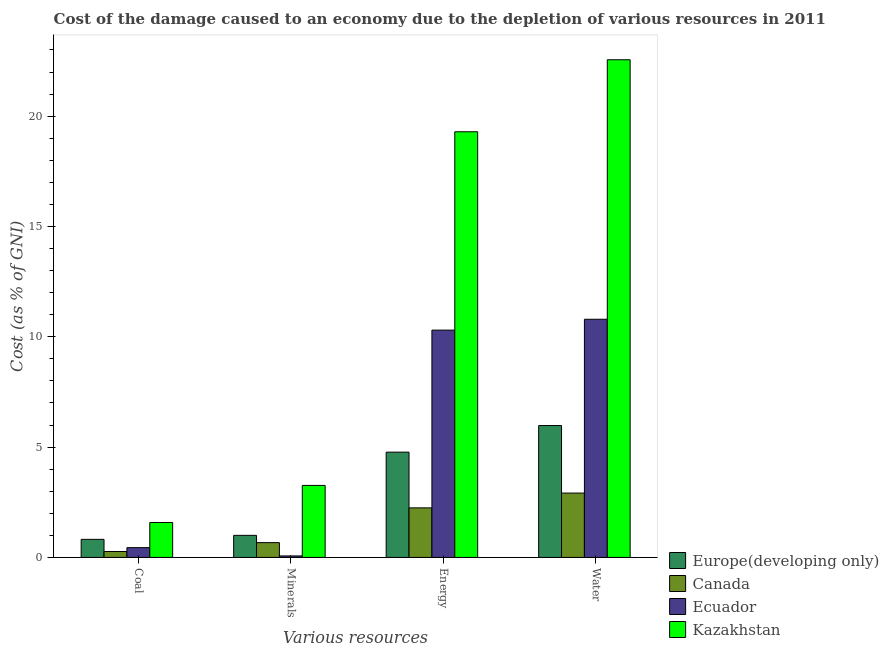How many different coloured bars are there?
Provide a succinct answer. 4. How many groups of bars are there?
Give a very brief answer. 4. What is the label of the 3rd group of bars from the left?
Your response must be concise. Energy. What is the cost of damage due to depletion of energy in Ecuador?
Offer a terse response. 10.3. Across all countries, what is the maximum cost of damage due to depletion of minerals?
Make the answer very short. 3.26. Across all countries, what is the minimum cost of damage due to depletion of water?
Give a very brief answer. 2.92. In which country was the cost of damage due to depletion of coal maximum?
Give a very brief answer. Kazakhstan. In which country was the cost of damage due to depletion of water minimum?
Your answer should be compact. Canada. What is the total cost of damage due to depletion of energy in the graph?
Your answer should be very brief. 36.61. What is the difference between the cost of damage due to depletion of coal in Ecuador and that in Canada?
Give a very brief answer. 0.18. What is the difference between the cost of damage due to depletion of minerals in Ecuador and the cost of damage due to depletion of energy in Canada?
Keep it short and to the point. -2.18. What is the average cost of damage due to depletion of coal per country?
Your answer should be very brief. 0.78. What is the difference between the cost of damage due to depletion of water and cost of damage due to depletion of coal in Canada?
Offer a very short reply. 2.65. What is the ratio of the cost of damage due to depletion of water in Ecuador to that in Europe(developing only)?
Provide a short and direct response. 1.81. Is the cost of damage due to depletion of coal in Ecuador less than that in Kazakhstan?
Keep it short and to the point. Yes. Is the difference between the cost of damage due to depletion of coal in Europe(developing only) and Canada greater than the difference between the cost of damage due to depletion of minerals in Europe(developing only) and Canada?
Your answer should be compact. Yes. What is the difference between the highest and the second highest cost of damage due to depletion of water?
Provide a short and direct response. 11.76. What is the difference between the highest and the lowest cost of damage due to depletion of water?
Your response must be concise. 19.64. Is the sum of the cost of damage due to depletion of water in Canada and Ecuador greater than the maximum cost of damage due to depletion of coal across all countries?
Give a very brief answer. Yes. Is it the case that in every country, the sum of the cost of damage due to depletion of coal and cost of damage due to depletion of minerals is greater than the sum of cost of damage due to depletion of energy and cost of damage due to depletion of water?
Your answer should be very brief. No. What does the 2nd bar from the left in Minerals represents?
Ensure brevity in your answer.  Canada. What does the 4th bar from the right in Minerals represents?
Make the answer very short. Europe(developing only). How many countries are there in the graph?
Your answer should be very brief. 4. What is the difference between two consecutive major ticks on the Y-axis?
Offer a terse response. 5. Does the graph contain grids?
Your answer should be compact. No. How many legend labels are there?
Your response must be concise. 4. How are the legend labels stacked?
Your answer should be compact. Vertical. What is the title of the graph?
Make the answer very short. Cost of the damage caused to an economy due to the depletion of various resources in 2011 . Does "Serbia" appear as one of the legend labels in the graph?
Your response must be concise. No. What is the label or title of the X-axis?
Ensure brevity in your answer.  Various resources. What is the label or title of the Y-axis?
Provide a short and direct response. Cost (as % of GNI). What is the Cost (as % of GNI) in Europe(developing only) in Coal?
Your response must be concise. 0.82. What is the Cost (as % of GNI) of Canada in Coal?
Your answer should be very brief. 0.27. What is the Cost (as % of GNI) in Ecuador in Coal?
Keep it short and to the point. 0.44. What is the Cost (as % of GNI) of Kazakhstan in Coal?
Your answer should be very brief. 1.58. What is the Cost (as % of GNI) of Europe(developing only) in Minerals?
Your answer should be very brief. 1. What is the Cost (as % of GNI) in Canada in Minerals?
Provide a short and direct response. 0.67. What is the Cost (as % of GNI) of Ecuador in Minerals?
Give a very brief answer. 0.07. What is the Cost (as % of GNI) in Kazakhstan in Minerals?
Make the answer very short. 3.26. What is the Cost (as % of GNI) in Europe(developing only) in Energy?
Ensure brevity in your answer.  4.77. What is the Cost (as % of GNI) in Canada in Energy?
Provide a short and direct response. 2.25. What is the Cost (as % of GNI) of Ecuador in Energy?
Keep it short and to the point. 10.3. What is the Cost (as % of GNI) in Kazakhstan in Energy?
Your response must be concise. 19.29. What is the Cost (as % of GNI) of Europe(developing only) in Water?
Give a very brief answer. 5.98. What is the Cost (as % of GNI) in Canada in Water?
Give a very brief answer. 2.92. What is the Cost (as % of GNI) of Ecuador in Water?
Offer a very short reply. 10.79. What is the Cost (as % of GNI) in Kazakhstan in Water?
Offer a terse response. 22.56. Across all Various resources, what is the maximum Cost (as % of GNI) in Europe(developing only)?
Make the answer very short. 5.98. Across all Various resources, what is the maximum Cost (as % of GNI) of Canada?
Offer a terse response. 2.92. Across all Various resources, what is the maximum Cost (as % of GNI) of Ecuador?
Offer a very short reply. 10.79. Across all Various resources, what is the maximum Cost (as % of GNI) of Kazakhstan?
Provide a short and direct response. 22.56. Across all Various resources, what is the minimum Cost (as % of GNI) of Europe(developing only)?
Keep it short and to the point. 0.82. Across all Various resources, what is the minimum Cost (as % of GNI) in Canada?
Provide a succinct answer. 0.27. Across all Various resources, what is the minimum Cost (as % of GNI) of Ecuador?
Provide a short and direct response. 0.07. Across all Various resources, what is the minimum Cost (as % of GNI) of Kazakhstan?
Provide a short and direct response. 1.58. What is the total Cost (as % of GNI) in Europe(developing only) in the graph?
Keep it short and to the point. 12.57. What is the total Cost (as % of GNI) of Canada in the graph?
Provide a succinct answer. 6.1. What is the total Cost (as % of GNI) of Ecuador in the graph?
Give a very brief answer. 21.61. What is the total Cost (as % of GNI) of Kazakhstan in the graph?
Make the answer very short. 46.7. What is the difference between the Cost (as % of GNI) of Europe(developing only) in Coal and that in Minerals?
Provide a succinct answer. -0.18. What is the difference between the Cost (as % of GNI) of Canada in Coal and that in Minerals?
Offer a terse response. -0.4. What is the difference between the Cost (as % of GNI) in Ecuador in Coal and that in Minerals?
Your response must be concise. 0.38. What is the difference between the Cost (as % of GNI) of Kazakhstan in Coal and that in Minerals?
Keep it short and to the point. -1.68. What is the difference between the Cost (as % of GNI) of Europe(developing only) in Coal and that in Energy?
Offer a terse response. -3.95. What is the difference between the Cost (as % of GNI) of Canada in Coal and that in Energy?
Ensure brevity in your answer.  -1.98. What is the difference between the Cost (as % of GNI) of Ecuador in Coal and that in Energy?
Give a very brief answer. -9.86. What is the difference between the Cost (as % of GNI) of Kazakhstan in Coal and that in Energy?
Keep it short and to the point. -17.71. What is the difference between the Cost (as % of GNI) in Europe(developing only) in Coal and that in Water?
Your response must be concise. -5.16. What is the difference between the Cost (as % of GNI) in Canada in Coal and that in Water?
Make the answer very short. -2.65. What is the difference between the Cost (as % of GNI) of Ecuador in Coal and that in Water?
Your response must be concise. -10.35. What is the difference between the Cost (as % of GNI) in Kazakhstan in Coal and that in Water?
Your answer should be compact. -20.97. What is the difference between the Cost (as % of GNI) in Europe(developing only) in Minerals and that in Energy?
Your answer should be very brief. -3.77. What is the difference between the Cost (as % of GNI) of Canada in Minerals and that in Energy?
Ensure brevity in your answer.  -1.58. What is the difference between the Cost (as % of GNI) of Ecuador in Minerals and that in Energy?
Give a very brief answer. -10.24. What is the difference between the Cost (as % of GNI) of Kazakhstan in Minerals and that in Energy?
Your answer should be compact. -16.03. What is the difference between the Cost (as % of GNI) in Europe(developing only) in Minerals and that in Water?
Give a very brief answer. -4.98. What is the difference between the Cost (as % of GNI) of Canada in Minerals and that in Water?
Provide a short and direct response. -2.25. What is the difference between the Cost (as % of GNI) of Ecuador in Minerals and that in Water?
Your response must be concise. -10.73. What is the difference between the Cost (as % of GNI) in Kazakhstan in Minerals and that in Water?
Your answer should be compact. -19.29. What is the difference between the Cost (as % of GNI) of Europe(developing only) in Energy and that in Water?
Offer a very short reply. -1.21. What is the difference between the Cost (as % of GNI) of Canada in Energy and that in Water?
Provide a short and direct response. -0.67. What is the difference between the Cost (as % of GNI) in Ecuador in Energy and that in Water?
Offer a terse response. -0.49. What is the difference between the Cost (as % of GNI) in Kazakhstan in Energy and that in Water?
Ensure brevity in your answer.  -3.26. What is the difference between the Cost (as % of GNI) of Europe(developing only) in Coal and the Cost (as % of GNI) of Canada in Minerals?
Your answer should be compact. 0.15. What is the difference between the Cost (as % of GNI) of Europe(developing only) in Coal and the Cost (as % of GNI) of Ecuador in Minerals?
Provide a succinct answer. 0.75. What is the difference between the Cost (as % of GNI) of Europe(developing only) in Coal and the Cost (as % of GNI) of Kazakhstan in Minerals?
Your answer should be compact. -2.44. What is the difference between the Cost (as % of GNI) of Canada in Coal and the Cost (as % of GNI) of Ecuador in Minerals?
Offer a terse response. 0.2. What is the difference between the Cost (as % of GNI) of Canada in Coal and the Cost (as % of GNI) of Kazakhstan in Minerals?
Your answer should be very brief. -3. What is the difference between the Cost (as % of GNI) in Ecuador in Coal and the Cost (as % of GNI) in Kazakhstan in Minerals?
Give a very brief answer. -2.82. What is the difference between the Cost (as % of GNI) in Europe(developing only) in Coal and the Cost (as % of GNI) in Canada in Energy?
Provide a succinct answer. -1.43. What is the difference between the Cost (as % of GNI) of Europe(developing only) in Coal and the Cost (as % of GNI) of Ecuador in Energy?
Keep it short and to the point. -9.48. What is the difference between the Cost (as % of GNI) of Europe(developing only) in Coal and the Cost (as % of GNI) of Kazakhstan in Energy?
Provide a succinct answer. -18.47. What is the difference between the Cost (as % of GNI) in Canada in Coal and the Cost (as % of GNI) in Ecuador in Energy?
Provide a succinct answer. -10.03. What is the difference between the Cost (as % of GNI) in Canada in Coal and the Cost (as % of GNI) in Kazakhstan in Energy?
Your answer should be compact. -19.02. What is the difference between the Cost (as % of GNI) in Ecuador in Coal and the Cost (as % of GNI) in Kazakhstan in Energy?
Your response must be concise. -18.85. What is the difference between the Cost (as % of GNI) in Europe(developing only) in Coal and the Cost (as % of GNI) in Canada in Water?
Ensure brevity in your answer.  -2.1. What is the difference between the Cost (as % of GNI) in Europe(developing only) in Coal and the Cost (as % of GNI) in Ecuador in Water?
Make the answer very short. -9.98. What is the difference between the Cost (as % of GNI) in Europe(developing only) in Coal and the Cost (as % of GNI) in Kazakhstan in Water?
Your answer should be compact. -21.74. What is the difference between the Cost (as % of GNI) of Canada in Coal and the Cost (as % of GNI) of Ecuador in Water?
Give a very brief answer. -10.53. What is the difference between the Cost (as % of GNI) in Canada in Coal and the Cost (as % of GNI) in Kazakhstan in Water?
Ensure brevity in your answer.  -22.29. What is the difference between the Cost (as % of GNI) in Ecuador in Coal and the Cost (as % of GNI) in Kazakhstan in Water?
Your answer should be compact. -22.11. What is the difference between the Cost (as % of GNI) of Europe(developing only) in Minerals and the Cost (as % of GNI) of Canada in Energy?
Make the answer very short. -1.25. What is the difference between the Cost (as % of GNI) in Europe(developing only) in Minerals and the Cost (as % of GNI) in Ecuador in Energy?
Keep it short and to the point. -9.3. What is the difference between the Cost (as % of GNI) of Europe(developing only) in Minerals and the Cost (as % of GNI) of Kazakhstan in Energy?
Your response must be concise. -18.29. What is the difference between the Cost (as % of GNI) of Canada in Minerals and the Cost (as % of GNI) of Ecuador in Energy?
Your answer should be very brief. -9.63. What is the difference between the Cost (as % of GNI) of Canada in Minerals and the Cost (as % of GNI) of Kazakhstan in Energy?
Your answer should be very brief. -18.62. What is the difference between the Cost (as % of GNI) in Ecuador in Minerals and the Cost (as % of GNI) in Kazakhstan in Energy?
Your answer should be very brief. -19.23. What is the difference between the Cost (as % of GNI) of Europe(developing only) in Minerals and the Cost (as % of GNI) of Canada in Water?
Offer a terse response. -1.92. What is the difference between the Cost (as % of GNI) in Europe(developing only) in Minerals and the Cost (as % of GNI) in Ecuador in Water?
Ensure brevity in your answer.  -9.79. What is the difference between the Cost (as % of GNI) in Europe(developing only) in Minerals and the Cost (as % of GNI) in Kazakhstan in Water?
Make the answer very short. -21.56. What is the difference between the Cost (as % of GNI) of Canada in Minerals and the Cost (as % of GNI) of Ecuador in Water?
Keep it short and to the point. -10.12. What is the difference between the Cost (as % of GNI) in Canada in Minerals and the Cost (as % of GNI) in Kazakhstan in Water?
Ensure brevity in your answer.  -21.89. What is the difference between the Cost (as % of GNI) of Ecuador in Minerals and the Cost (as % of GNI) of Kazakhstan in Water?
Your response must be concise. -22.49. What is the difference between the Cost (as % of GNI) of Europe(developing only) in Energy and the Cost (as % of GNI) of Canada in Water?
Your response must be concise. 1.85. What is the difference between the Cost (as % of GNI) in Europe(developing only) in Energy and the Cost (as % of GNI) in Ecuador in Water?
Offer a very short reply. -6.02. What is the difference between the Cost (as % of GNI) in Europe(developing only) in Energy and the Cost (as % of GNI) in Kazakhstan in Water?
Your answer should be compact. -17.78. What is the difference between the Cost (as % of GNI) in Canada in Energy and the Cost (as % of GNI) in Ecuador in Water?
Keep it short and to the point. -8.55. What is the difference between the Cost (as % of GNI) of Canada in Energy and the Cost (as % of GNI) of Kazakhstan in Water?
Ensure brevity in your answer.  -20.31. What is the difference between the Cost (as % of GNI) of Ecuador in Energy and the Cost (as % of GNI) of Kazakhstan in Water?
Keep it short and to the point. -12.25. What is the average Cost (as % of GNI) in Europe(developing only) per Various resources?
Ensure brevity in your answer.  3.14. What is the average Cost (as % of GNI) in Canada per Various resources?
Provide a succinct answer. 1.53. What is the average Cost (as % of GNI) in Ecuador per Various resources?
Provide a succinct answer. 5.4. What is the average Cost (as % of GNI) of Kazakhstan per Various resources?
Provide a succinct answer. 11.67. What is the difference between the Cost (as % of GNI) of Europe(developing only) and Cost (as % of GNI) of Canada in Coal?
Your answer should be very brief. 0.55. What is the difference between the Cost (as % of GNI) of Europe(developing only) and Cost (as % of GNI) of Ecuador in Coal?
Offer a terse response. 0.38. What is the difference between the Cost (as % of GNI) in Europe(developing only) and Cost (as % of GNI) in Kazakhstan in Coal?
Your response must be concise. -0.76. What is the difference between the Cost (as % of GNI) of Canada and Cost (as % of GNI) of Ecuador in Coal?
Provide a succinct answer. -0.18. What is the difference between the Cost (as % of GNI) in Canada and Cost (as % of GNI) in Kazakhstan in Coal?
Offer a terse response. -1.31. What is the difference between the Cost (as % of GNI) of Ecuador and Cost (as % of GNI) of Kazakhstan in Coal?
Give a very brief answer. -1.14. What is the difference between the Cost (as % of GNI) of Europe(developing only) and Cost (as % of GNI) of Canada in Minerals?
Provide a succinct answer. 0.33. What is the difference between the Cost (as % of GNI) in Europe(developing only) and Cost (as % of GNI) in Ecuador in Minerals?
Offer a terse response. 0.93. What is the difference between the Cost (as % of GNI) in Europe(developing only) and Cost (as % of GNI) in Kazakhstan in Minerals?
Your response must be concise. -2.26. What is the difference between the Cost (as % of GNI) of Canada and Cost (as % of GNI) of Ecuador in Minerals?
Ensure brevity in your answer.  0.6. What is the difference between the Cost (as % of GNI) of Canada and Cost (as % of GNI) of Kazakhstan in Minerals?
Your response must be concise. -2.59. What is the difference between the Cost (as % of GNI) of Ecuador and Cost (as % of GNI) of Kazakhstan in Minerals?
Your response must be concise. -3.2. What is the difference between the Cost (as % of GNI) in Europe(developing only) and Cost (as % of GNI) in Canada in Energy?
Keep it short and to the point. 2.53. What is the difference between the Cost (as % of GNI) in Europe(developing only) and Cost (as % of GNI) in Ecuador in Energy?
Offer a terse response. -5.53. What is the difference between the Cost (as % of GNI) of Europe(developing only) and Cost (as % of GNI) of Kazakhstan in Energy?
Provide a short and direct response. -14.52. What is the difference between the Cost (as % of GNI) of Canada and Cost (as % of GNI) of Ecuador in Energy?
Your answer should be compact. -8.06. What is the difference between the Cost (as % of GNI) of Canada and Cost (as % of GNI) of Kazakhstan in Energy?
Offer a terse response. -17.05. What is the difference between the Cost (as % of GNI) of Ecuador and Cost (as % of GNI) of Kazakhstan in Energy?
Give a very brief answer. -8.99. What is the difference between the Cost (as % of GNI) of Europe(developing only) and Cost (as % of GNI) of Canada in Water?
Offer a very short reply. 3.06. What is the difference between the Cost (as % of GNI) of Europe(developing only) and Cost (as % of GNI) of Ecuador in Water?
Your response must be concise. -4.82. What is the difference between the Cost (as % of GNI) of Europe(developing only) and Cost (as % of GNI) of Kazakhstan in Water?
Ensure brevity in your answer.  -16.58. What is the difference between the Cost (as % of GNI) of Canada and Cost (as % of GNI) of Ecuador in Water?
Your answer should be compact. -7.88. What is the difference between the Cost (as % of GNI) in Canada and Cost (as % of GNI) in Kazakhstan in Water?
Your response must be concise. -19.64. What is the difference between the Cost (as % of GNI) of Ecuador and Cost (as % of GNI) of Kazakhstan in Water?
Provide a short and direct response. -11.76. What is the ratio of the Cost (as % of GNI) in Europe(developing only) in Coal to that in Minerals?
Ensure brevity in your answer.  0.82. What is the ratio of the Cost (as % of GNI) in Canada in Coal to that in Minerals?
Your answer should be very brief. 0.4. What is the ratio of the Cost (as % of GNI) of Ecuador in Coal to that in Minerals?
Make the answer very short. 6.57. What is the ratio of the Cost (as % of GNI) of Kazakhstan in Coal to that in Minerals?
Provide a succinct answer. 0.48. What is the ratio of the Cost (as % of GNI) of Europe(developing only) in Coal to that in Energy?
Give a very brief answer. 0.17. What is the ratio of the Cost (as % of GNI) of Canada in Coal to that in Energy?
Provide a succinct answer. 0.12. What is the ratio of the Cost (as % of GNI) of Ecuador in Coal to that in Energy?
Your answer should be compact. 0.04. What is the ratio of the Cost (as % of GNI) of Kazakhstan in Coal to that in Energy?
Provide a short and direct response. 0.08. What is the ratio of the Cost (as % of GNI) of Europe(developing only) in Coal to that in Water?
Offer a very short reply. 0.14. What is the ratio of the Cost (as % of GNI) in Canada in Coal to that in Water?
Offer a terse response. 0.09. What is the ratio of the Cost (as % of GNI) of Ecuador in Coal to that in Water?
Ensure brevity in your answer.  0.04. What is the ratio of the Cost (as % of GNI) in Kazakhstan in Coal to that in Water?
Make the answer very short. 0.07. What is the ratio of the Cost (as % of GNI) in Europe(developing only) in Minerals to that in Energy?
Your response must be concise. 0.21. What is the ratio of the Cost (as % of GNI) in Canada in Minerals to that in Energy?
Make the answer very short. 0.3. What is the ratio of the Cost (as % of GNI) in Ecuador in Minerals to that in Energy?
Keep it short and to the point. 0.01. What is the ratio of the Cost (as % of GNI) in Kazakhstan in Minerals to that in Energy?
Your answer should be compact. 0.17. What is the ratio of the Cost (as % of GNI) in Europe(developing only) in Minerals to that in Water?
Offer a terse response. 0.17. What is the ratio of the Cost (as % of GNI) in Canada in Minerals to that in Water?
Offer a terse response. 0.23. What is the ratio of the Cost (as % of GNI) of Ecuador in Minerals to that in Water?
Your answer should be compact. 0.01. What is the ratio of the Cost (as % of GNI) in Kazakhstan in Minerals to that in Water?
Provide a succinct answer. 0.14. What is the ratio of the Cost (as % of GNI) of Europe(developing only) in Energy to that in Water?
Provide a short and direct response. 0.8. What is the ratio of the Cost (as % of GNI) in Canada in Energy to that in Water?
Your answer should be very brief. 0.77. What is the ratio of the Cost (as % of GNI) of Ecuador in Energy to that in Water?
Offer a very short reply. 0.95. What is the ratio of the Cost (as % of GNI) in Kazakhstan in Energy to that in Water?
Keep it short and to the point. 0.86. What is the difference between the highest and the second highest Cost (as % of GNI) of Europe(developing only)?
Make the answer very short. 1.21. What is the difference between the highest and the second highest Cost (as % of GNI) in Canada?
Provide a succinct answer. 0.67. What is the difference between the highest and the second highest Cost (as % of GNI) in Ecuador?
Make the answer very short. 0.49. What is the difference between the highest and the second highest Cost (as % of GNI) in Kazakhstan?
Make the answer very short. 3.26. What is the difference between the highest and the lowest Cost (as % of GNI) in Europe(developing only)?
Your response must be concise. 5.16. What is the difference between the highest and the lowest Cost (as % of GNI) of Canada?
Your answer should be compact. 2.65. What is the difference between the highest and the lowest Cost (as % of GNI) of Ecuador?
Your answer should be compact. 10.73. What is the difference between the highest and the lowest Cost (as % of GNI) of Kazakhstan?
Your response must be concise. 20.97. 